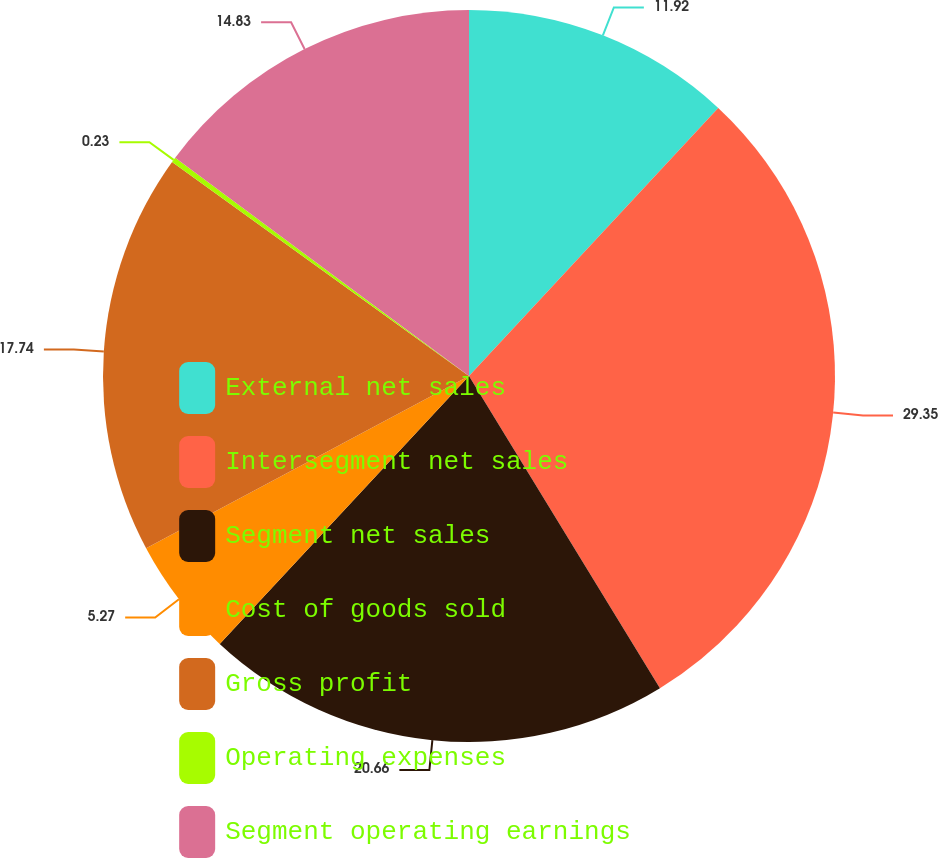<chart> <loc_0><loc_0><loc_500><loc_500><pie_chart><fcel>External net sales<fcel>Intersegment net sales<fcel>Segment net sales<fcel>Cost of goods sold<fcel>Gross profit<fcel>Operating expenses<fcel>Segment operating earnings<nl><fcel>11.92%<fcel>29.34%<fcel>20.66%<fcel>5.27%<fcel>17.74%<fcel>0.23%<fcel>14.83%<nl></chart> 